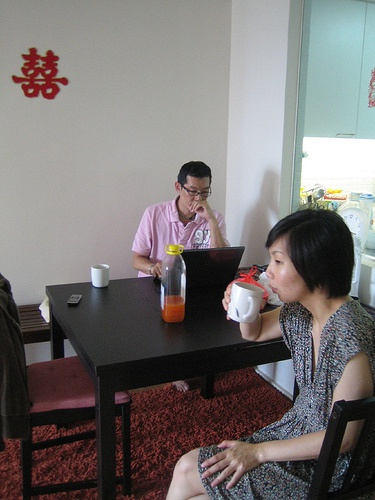Describe the objects in this image and their specific colors. I can see people in gray, black, and darkgray tones, dining table in gray and black tones, chair in gray, black, maroon, and brown tones, people in gray, darkgray, pink, and brown tones, and chair in gray, black, and maroon tones in this image. 